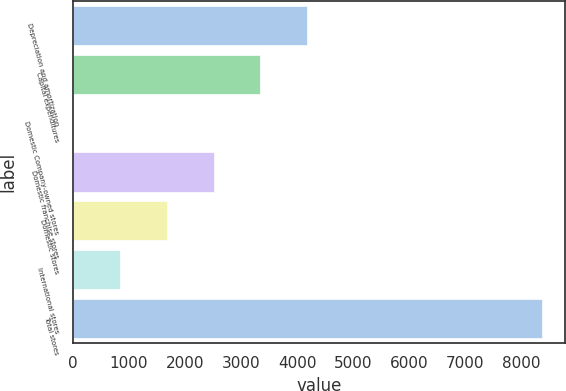Convert chart. <chart><loc_0><loc_0><loc_500><loc_500><bar_chart><fcel>Depreciation and amortization<fcel>Capital expenditures<fcel>Domestic Company-owned stores<fcel>Domestic franchise stores<fcel>Domestic stores<fcel>International stores<fcel>Total stores<nl><fcel>4184.1<fcel>3347.72<fcel>2.2<fcel>2511.34<fcel>1674.96<fcel>838.58<fcel>8366<nl></chart> 